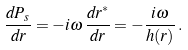Convert formula to latex. <formula><loc_0><loc_0><loc_500><loc_500>\frac { d P _ { s } } { d r } = - i \omega \, \frac { d r ^ { * } } { d r } = - \frac { i \omega } { h ( r ) } \, .</formula> 